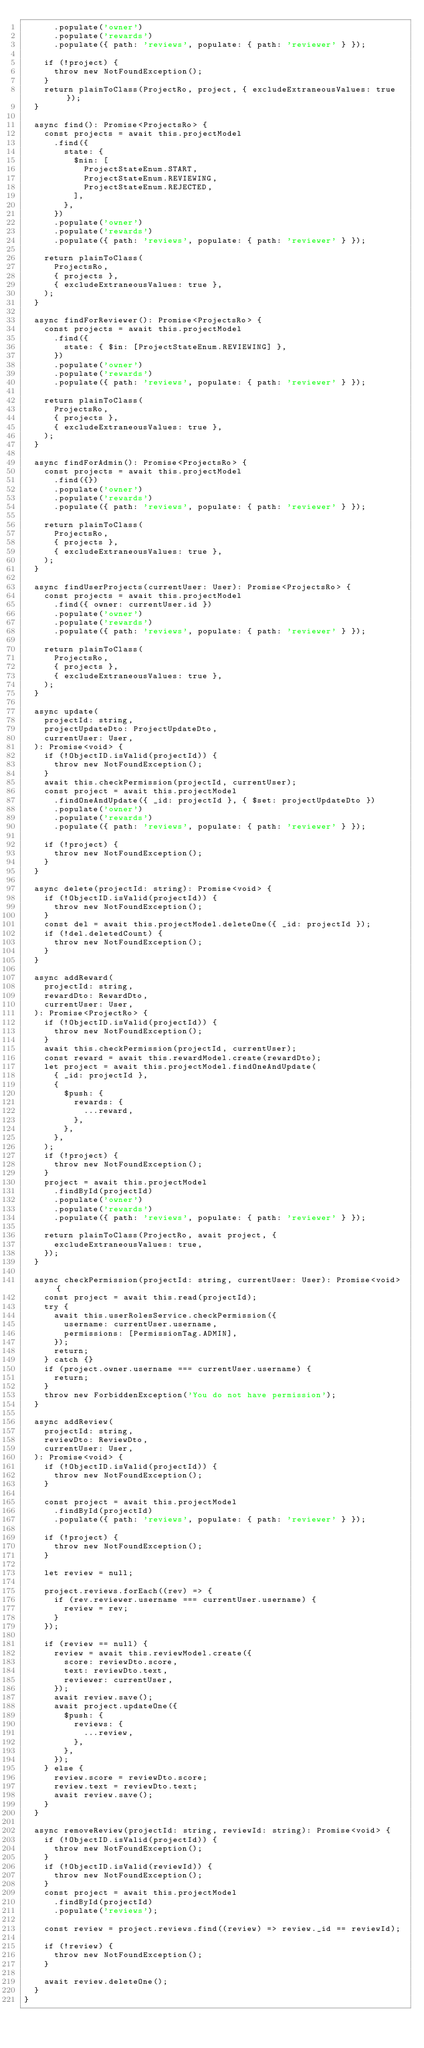Convert code to text. <code><loc_0><loc_0><loc_500><loc_500><_TypeScript_>      .populate('owner')
      .populate('rewards')
      .populate({ path: 'reviews', populate: { path: 'reviewer' } });

    if (!project) {
      throw new NotFoundException();
    }
    return plainToClass(ProjectRo, project, { excludeExtraneousValues: true });
  }

  async find(): Promise<ProjectsRo> {
    const projects = await this.projectModel
      .find({
        state: {
          $nin: [
            ProjectStateEnum.START,
            ProjectStateEnum.REVIEWING,
            ProjectStateEnum.REJECTED,
          ],
        },
      })
      .populate('owner')
      .populate('rewards')
      .populate({ path: 'reviews', populate: { path: 'reviewer' } });

    return plainToClass(
      ProjectsRo,
      { projects },
      { excludeExtraneousValues: true },
    );
  }

  async findForReviewer(): Promise<ProjectsRo> {
    const projects = await this.projectModel
      .find({
        state: { $in: [ProjectStateEnum.REVIEWING] },
      })
      .populate('owner')
      .populate('rewards')
      .populate({ path: 'reviews', populate: { path: 'reviewer' } });

    return plainToClass(
      ProjectsRo,
      { projects },
      { excludeExtraneousValues: true },
    );
  }

  async findForAdmin(): Promise<ProjectsRo> {
    const projects = await this.projectModel
      .find({})
      .populate('owner')
      .populate('rewards')
      .populate({ path: 'reviews', populate: { path: 'reviewer' } });

    return plainToClass(
      ProjectsRo,
      { projects },
      { excludeExtraneousValues: true },
    );
  }

  async findUserProjects(currentUser: User): Promise<ProjectsRo> {
    const projects = await this.projectModel
      .find({ owner: currentUser.id })
      .populate('owner')
      .populate('rewards')
      .populate({ path: 'reviews', populate: { path: 'reviewer' } });

    return plainToClass(
      ProjectsRo,
      { projects },
      { excludeExtraneousValues: true },
    );
  }

  async update(
    projectId: string,
    projectUpdateDto: ProjectUpdateDto,
    currentUser: User,
  ): Promise<void> {
    if (!ObjectID.isValid(projectId)) {
      throw new NotFoundException();
    }
    await this.checkPermission(projectId, currentUser);
    const project = await this.projectModel
      .findOneAndUpdate({ _id: projectId }, { $set: projectUpdateDto })
      .populate('owner')
      .populate('rewards')
      .populate({ path: 'reviews', populate: { path: 'reviewer' } });

    if (!project) {
      throw new NotFoundException();
    }
  }

  async delete(projectId: string): Promise<void> {
    if (!ObjectID.isValid(projectId)) {
      throw new NotFoundException();
    }
    const del = await this.projectModel.deleteOne({ _id: projectId });
    if (!del.deletedCount) {
      throw new NotFoundException();
    }
  }

  async addReward(
    projectId: string,
    rewardDto: RewardDto,
    currentUser: User,
  ): Promise<ProjectRo> {
    if (!ObjectID.isValid(projectId)) {
      throw new NotFoundException();
    }
    await this.checkPermission(projectId, currentUser);
    const reward = await this.rewardModel.create(rewardDto);
    let project = await this.projectModel.findOneAndUpdate(
      { _id: projectId },
      {
        $push: {
          rewards: {
            ...reward,
          },
        },
      },
    );
    if (!project) {
      throw new NotFoundException();
    }
    project = await this.projectModel
      .findById(projectId)
      .populate('owner')
      .populate('rewards')
      .populate({ path: 'reviews', populate: { path: 'reviewer' } });

    return plainToClass(ProjectRo, await project, {
      excludeExtraneousValues: true,
    });
  }

  async checkPermission(projectId: string, currentUser: User): Promise<void> {
    const project = await this.read(projectId);
    try {
      await this.userRolesService.checkPermission({
        username: currentUser.username,
        permissions: [PermissionTag.ADMIN],
      });
      return;
    } catch {}
    if (project.owner.username === currentUser.username) {
      return;
    }
    throw new ForbiddenException('You do not have permission');
  }

  async addReview(
    projectId: string,
    reviewDto: ReviewDto,
    currentUser: User,
  ): Promise<void> {
    if (!ObjectID.isValid(projectId)) {
      throw new NotFoundException();
    }

    const project = await this.projectModel
      .findById(projectId)
      .populate({ path: 'reviews', populate: { path: 'reviewer' } });

    if (!project) {
      throw new NotFoundException();
    }

    let review = null;

    project.reviews.forEach((rev) => {
      if (rev.reviewer.username === currentUser.username) {
        review = rev;
      }
    });

    if (review == null) {
      review = await this.reviewModel.create({
        score: reviewDto.score,
        text: reviewDto.text,
        reviewer: currentUser,
      });
      await review.save();
      await project.updateOne({
        $push: {
          reviews: {
            ...review,
          },
        },
      });
    } else {
      review.score = reviewDto.score;
      review.text = reviewDto.text;
      await review.save();
    }
  }

  async removeReview(projectId: string, reviewId: string): Promise<void> {
    if (!ObjectID.isValid(projectId)) {
      throw new NotFoundException();
    }
    if (!ObjectID.isValid(reviewId)) {
      throw new NotFoundException();
    }
    const project = await this.projectModel
      .findById(projectId)
      .populate('reviews');

    const review = project.reviews.find((review) => review._id == reviewId);

    if (!review) {
      throw new NotFoundException();
    }

    await review.deleteOne();
  }
}
</code> 